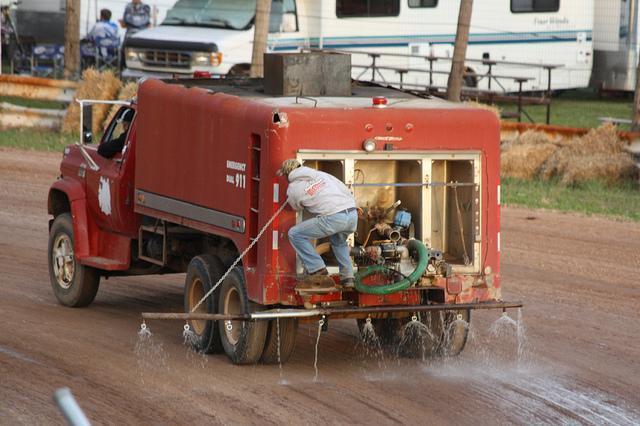How did he get on back of the truck?
Choose the correct response and explain in the format: 'Answer: answer
Rationale: rationale.'
Options: Climbed on, fell on, lives there, jumped on. Answer: climbed on.
Rationale: The man hopped onto the truck. 